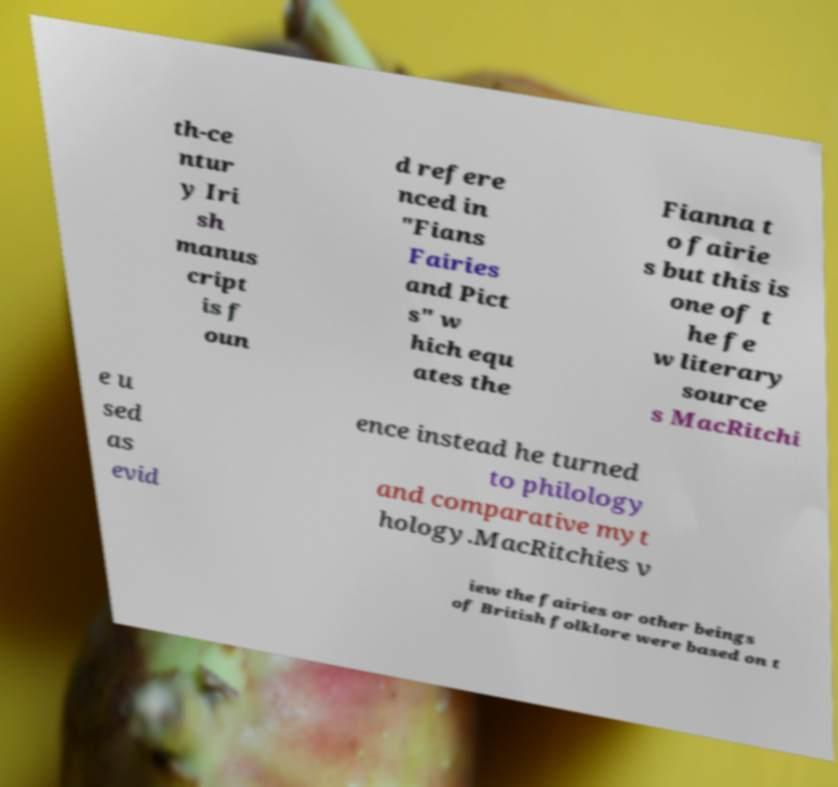I need the written content from this picture converted into text. Can you do that? th-ce ntur y Iri sh manus cript is f oun d refere nced in "Fians Fairies and Pict s" w hich equ ates the Fianna t o fairie s but this is one of t he fe w literary source s MacRitchi e u sed as evid ence instead he turned to philology and comparative myt hology.MacRitchies v iew the fairies or other beings of British folklore were based on t 